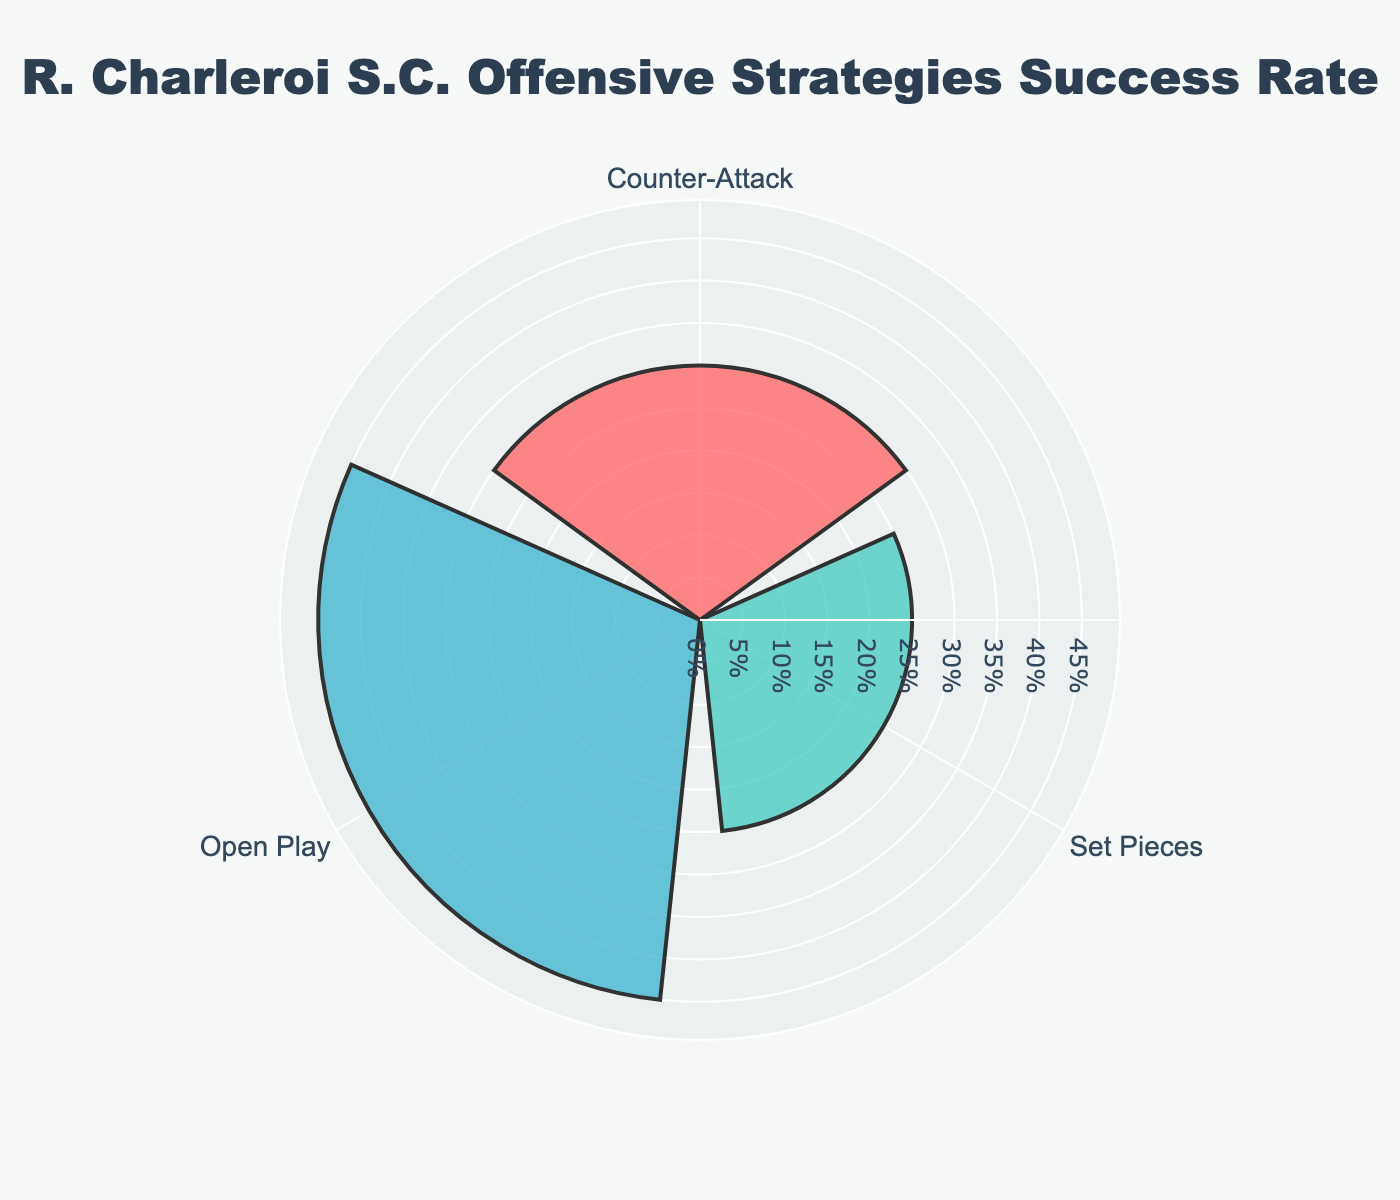What is the title of the figure? The title is located at the top of the figure. It reads "R. Charleroi S.C. Offensive Strategies Success Rate".
Answer: R. Charleroi S.C. Offensive Strategies Success Rate What are the three different offensive strategies shown in the figure? The different offensive strategies are plotted around the polar axis. They are "Counter-Attack", "Set Pieces", and "Open Play".
Answer: Counter-Attack, Set Pieces, Open Play Which offensive strategy has the highest success rate? By comparing the lengths of the bars, the longest bar represents "Open Play" with the highest success rate of 45%.
Answer: Open Play What is the success rate of Set Pieces? The bar labeled "Set Pieces" indicates a success rate of 25%.
Answer: 25% How much greater is the success rate of Open Play compared to Counter-Attack? The success rate of Open Play (45%) minus the success rate of Counter-Attack (30%) gives the difference.
Answer: 15% What is the sum of the success rates of all the offensive strategies? Add the success rates of Counter-Attack, Set Pieces, and Open Play: 30% + 25% + 45%.
Answer: 100% Which offensive strategy has the lowest success rate? The shortest bar represents "Set Pieces" with the lowest success rate of 25%.
Answer: Set Pieces How does the success rate of "Open Play" compare with the average success rate of all strategies? First, calculate the average success rate: (30% + 25% + 45%) / 3 = 33.33%. Open Play (45%) is greater than the average (33.33%).
Answer: Greater than What are the colors of the markers for each of the offensive strategies? The markers' colors for "Counter-Attack", "Set Pieces", and "Open Play" are red, teal, and blue respectively.
Answer: Red, Teal, Blue How many different data points are represented in the rose chart? Count the number of bars, each corresponding to a strategy. There are three data points.
Answer: Three 